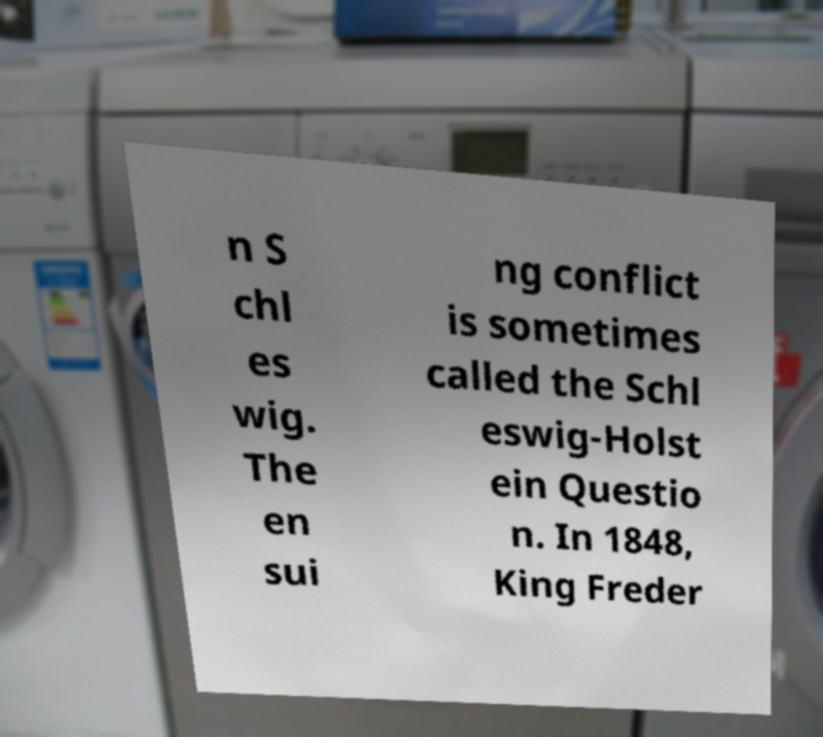Please read and relay the text visible in this image. What does it say? n S chl es wig. The en sui ng conflict is sometimes called the Schl eswig-Holst ein Questio n. In 1848, King Freder 